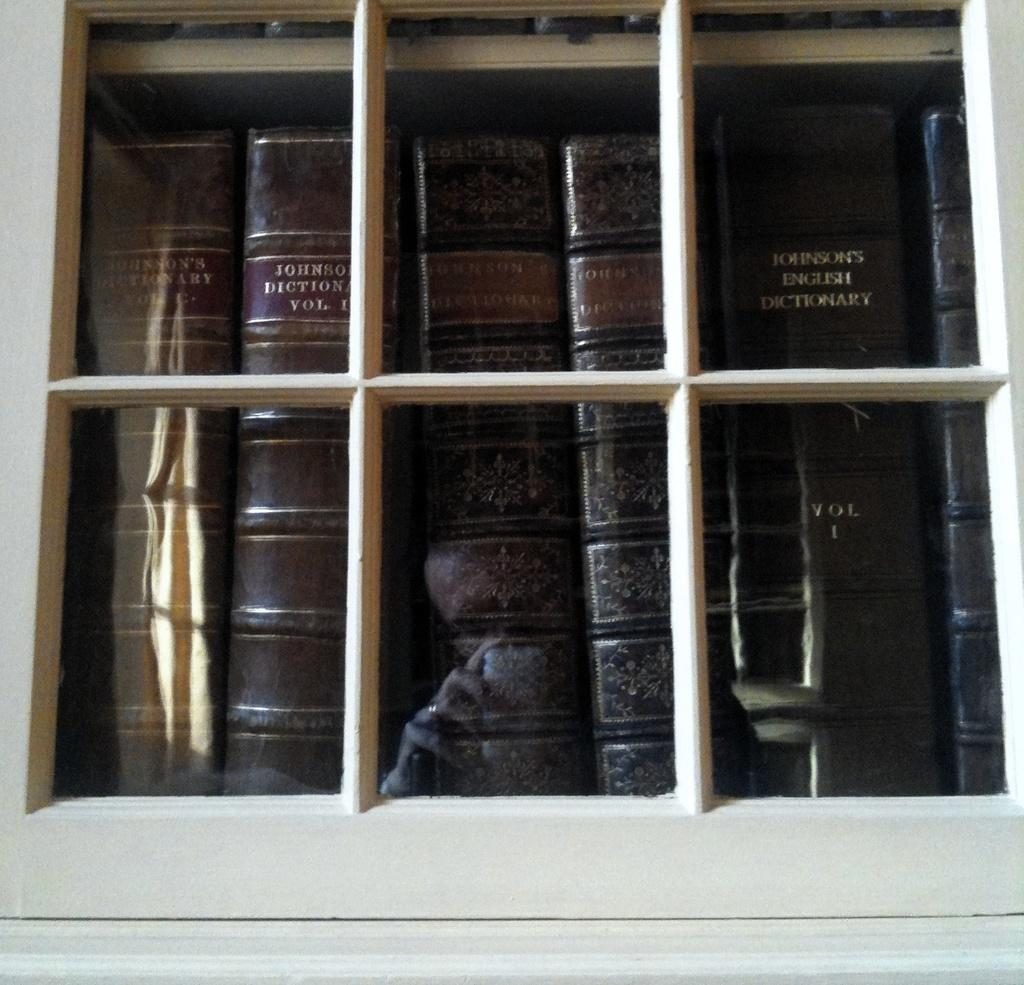<image>
Create a compact narrative representing the image presented. Old leather bound Johnson's Dictionaries are standing side by side behind a glass door. 